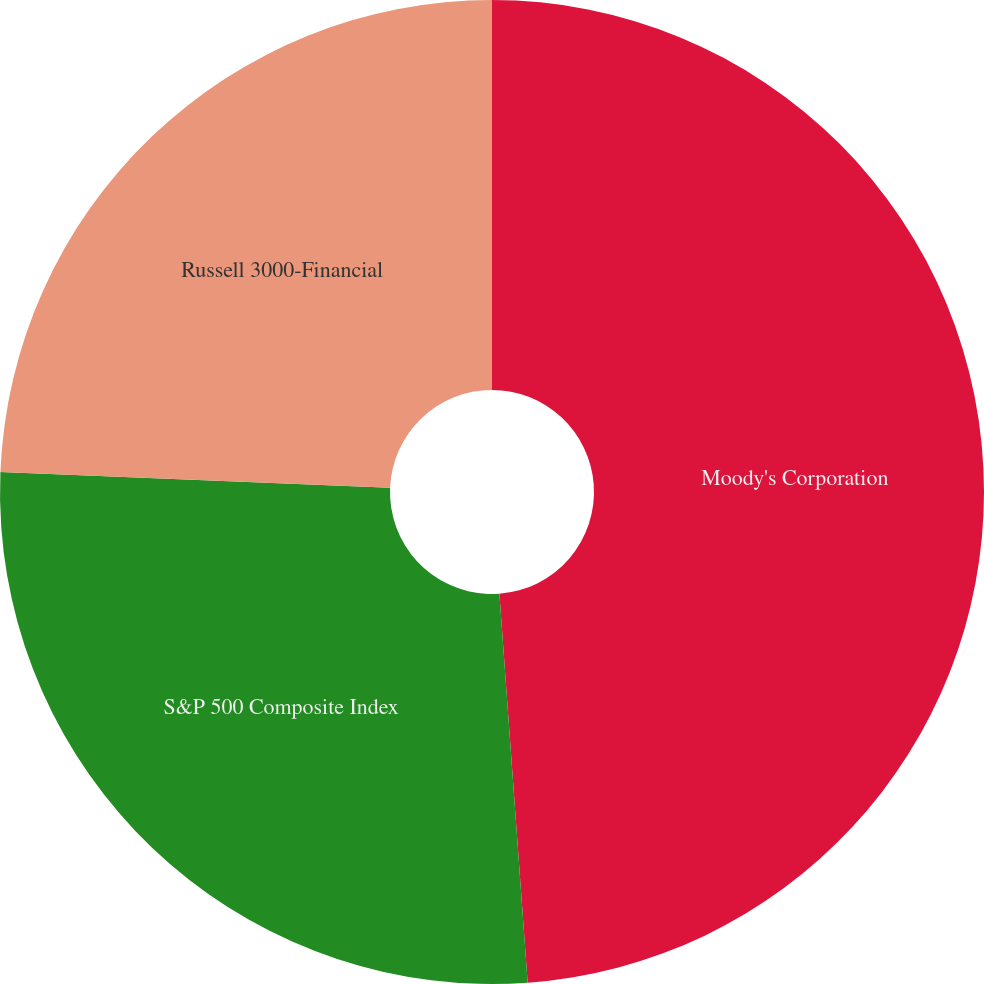Convert chart. <chart><loc_0><loc_0><loc_500><loc_500><pie_chart><fcel>Moody's Corporation<fcel>S&P 500 Composite Index<fcel>Russell 3000-Financial<nl><fcel>48.84%<fcel>26.8%<fcel>24.35%<nl></chart> 